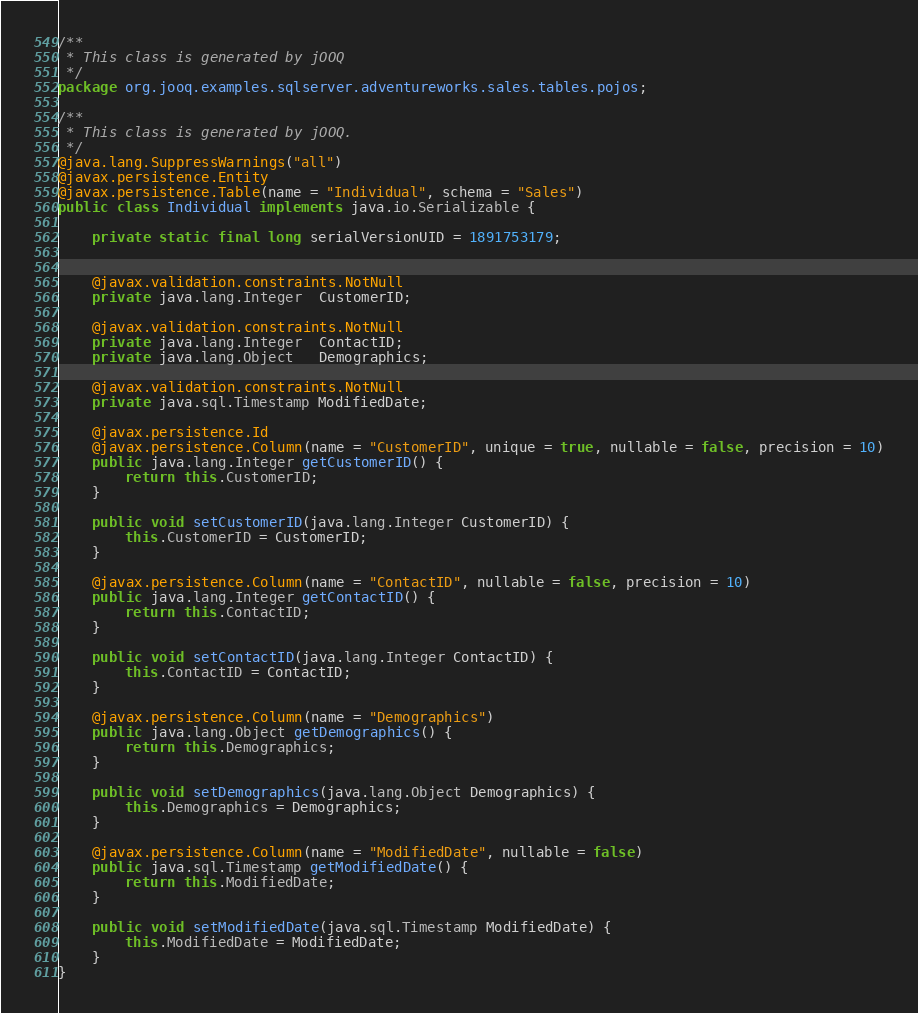<code> <loc_0><loc_0><loc_500><loc_500><_Java_>/**
 * This class is generated by jOOQ
 */
package org.jooq.examples.sqlserver.adventureworks.sales.tables.pojos;

/**
 * This class is generated by jOOQ.
 */
@java.lang.SuppressWarnings("all")
@javax.persistence.Entity
@javax.persistence.Table(name = "Individual", schema = "Sales")
public class Individual implements java.io.Serializable {

	private static final long serialVersionUID = 1891753179;


	@javax.validation.constraints.NotNull
	private java.lang.Integer  CustomerID;

	@javax.validation.constraints.NotNull
	private java.lang.Integer  ContactID;
	private java.lang.Object   Demographics;

	@javax.validation.constraints.NotNull
	private java.sql.Timestamp ModifiedDate;

	@javax.persistence.Id
	@javax.persistence.Column(name = "CustomerID", unique = true, nullable = false, precision = 10)
	public java.lang.Integer getCustomerID() {
		return this.CustomerID;
	}

	public void setCustomerID(java.lang.Integer CustomerID) {
		this.CustomerID = CustomerID;
	}

	@javax.persistence.Column(name = "ContactID", nullable = false, precision = 10)
	public java.lang.Integer getContactID() {
		return this.ContactID;
	}

	public void setContactID(java.lang.Integer ContactID) {
		this.ContactID = ContactID;
	}

	@javax.persistence.Column(name = "Demographics")
	public java.lang.Object getDemographics() {
		return this.Demographics;
	}

	public void setDemographics(java.lang.Object Demographics) {
		this.Demographics = Demographics;
	}

	@javax.persistence.Column(name = "ModifiedDate", nullable = false)
	public java.sql.Timestamp getModifiedDate() {
		return this.ModifiedDate;
	}

	public void setModifiedDate(java.sql.Timestamp ModifiedDate) {
		this.ModifiedDate = ModifiedDate;
	}
}
</code> 